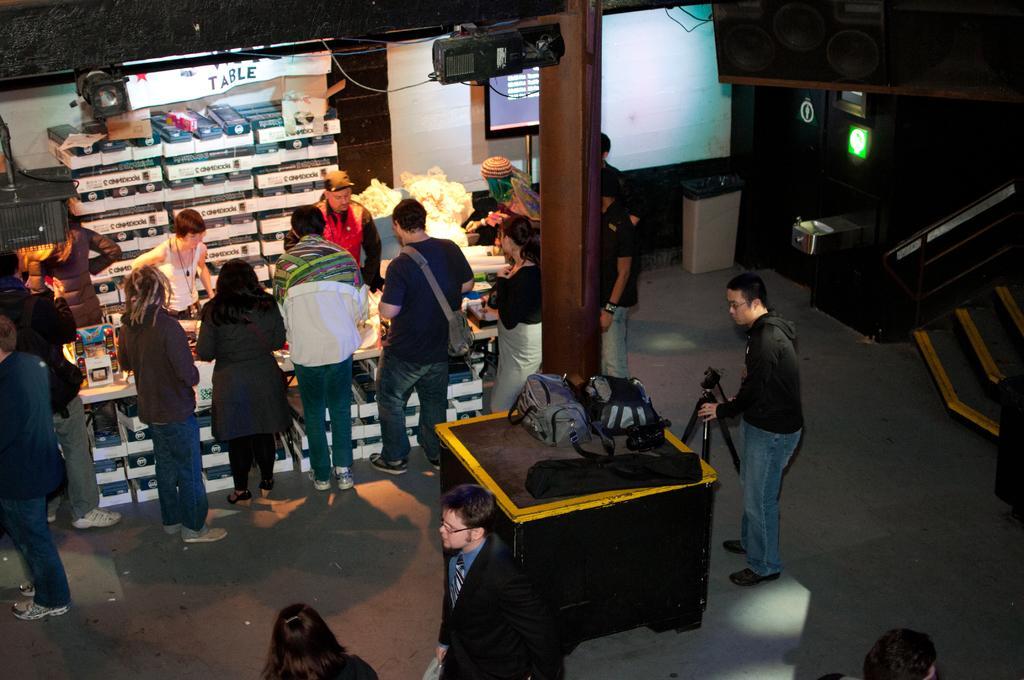How would you summarize this image in a sentence or two? In this image there are group of people standing, television attached to the pole, a person holding a tripod stand, cardboard boxes arranged in an order,bags on the table. 